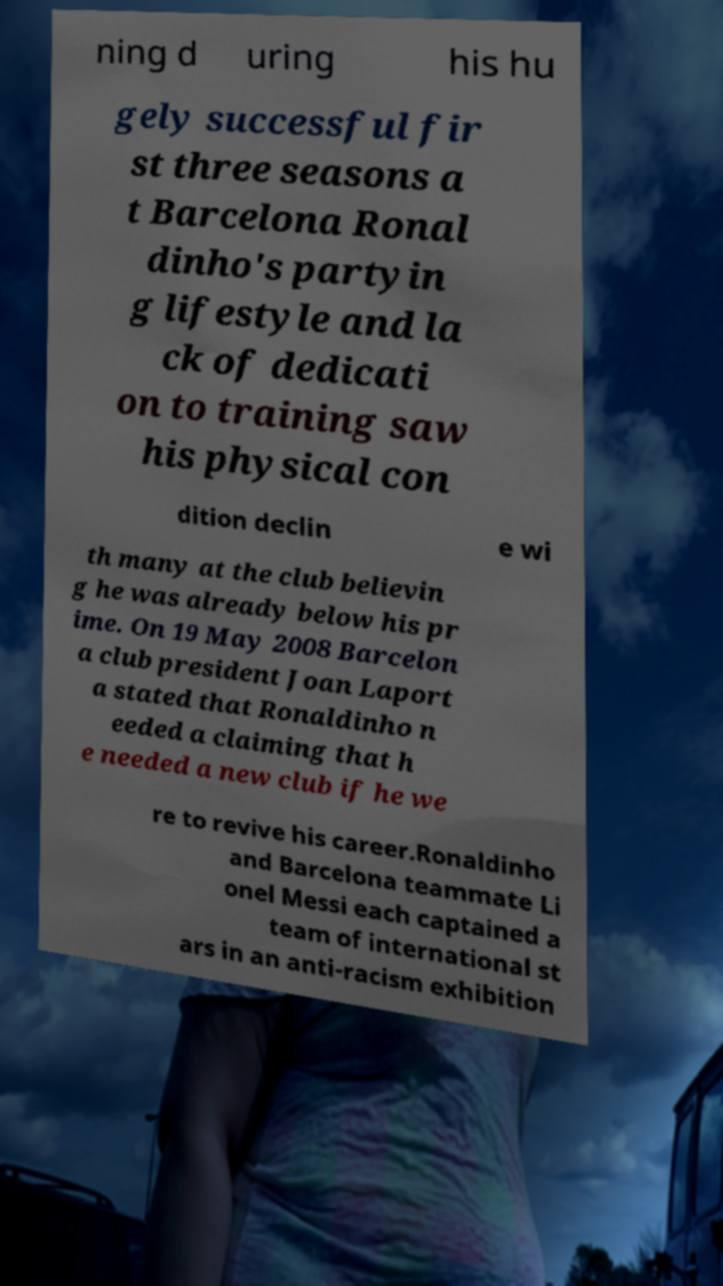Please identify and transcribe the text found in this image. ning d uring his hu gely successful fir st three seasons a t Barcelona Ronal dinho's partyin g lifestyle and la ck of dedicati on to training saw his physical con dition declin e wi th many at the club believin g he was already below his pr ime. On 19 May 2008 Barcelon a club president Joan Laport a stated that Ronaldinho n eeded a claiming that h e needed a new club if he we re to revive his career.Ronaldinho and Barcelona teammate Li onel Messi each captained a team of international st ars in an anti-racism exhibition 